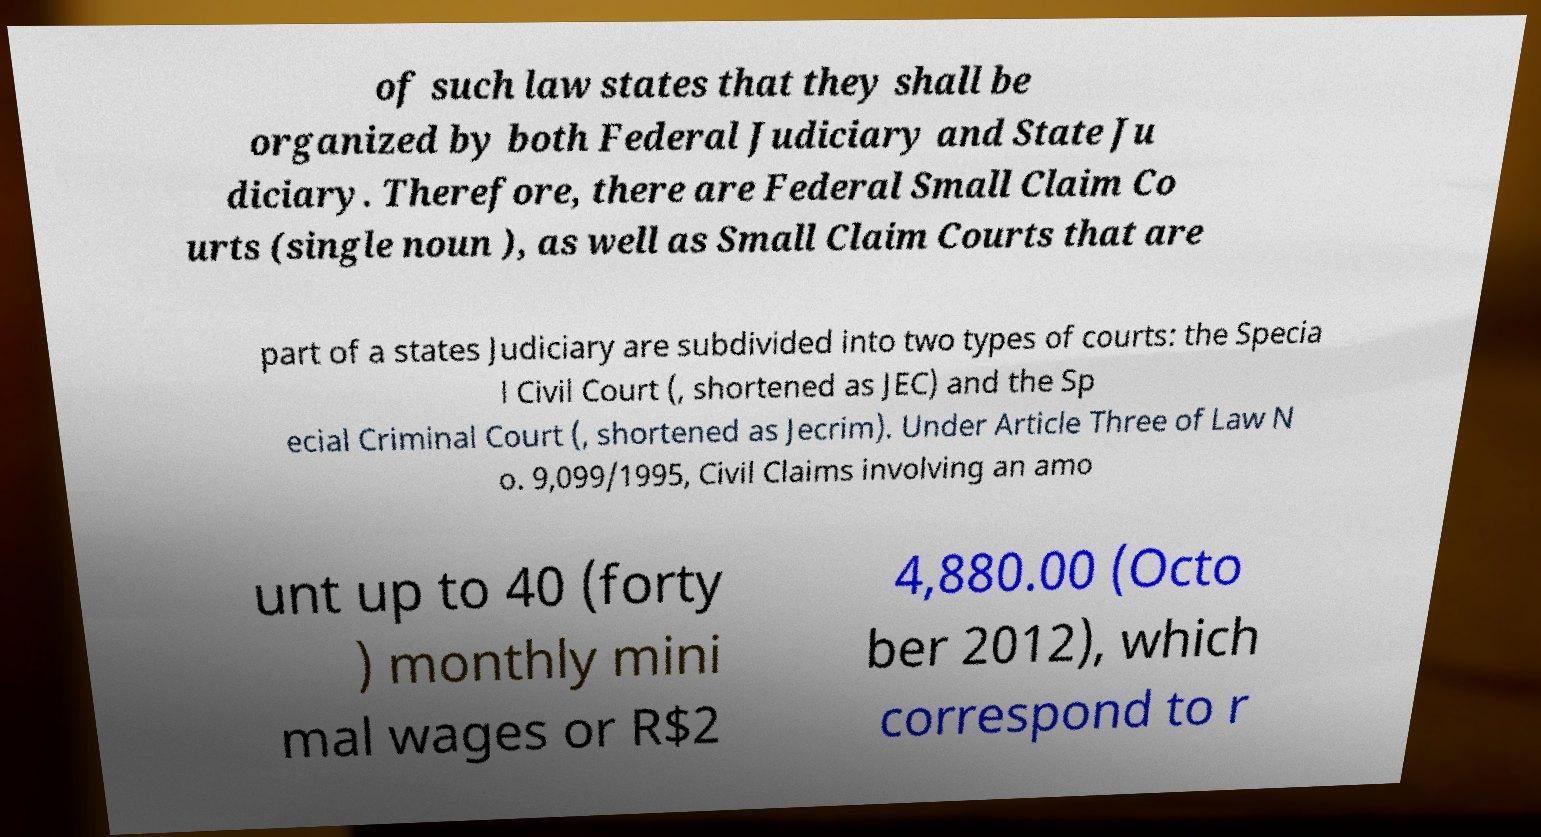Please identify and transcribe the text found in this image. of such law states that they shall be organized by both Federal Judiciary and State Ju diciary. Therefore, there are Federal Small Claim Co urts (single noun ), as well as Small Claim Courts that are part of a states Judiciary are subdivided into two types of courts: the Specia l Civil Court (, shortened as JEC) and the Sp ecial Criminal Court (, shortened as Jecrim). Under Article Three of Law N o. 9,099/1995, Civil Claims involving an amo unt up to 40 (forty ) monthly mini mal wages or R$2 4,880.00 (Octo ber 2012), which correspond to r 